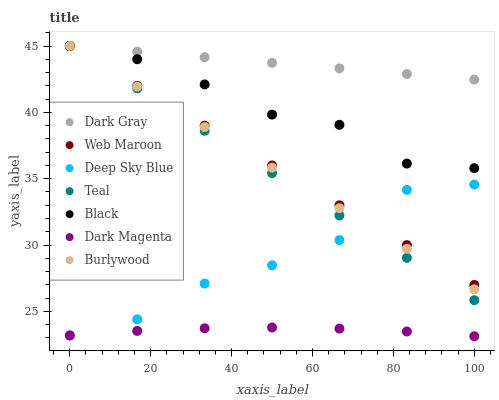Does Dark Magenta have the minimum area under the curve?
Answer yes or no. Yes. Does Dark Gray have the maximum area under the curve?
Answer yes or no. Yes. Does Burlywood have the minimum area under the curve?
Answer yes or no. No. Does Burlywood have the maximum area under the curve?
Answer yes or no. No. Is Teal the smoothest?
Answer yes or no. Yes. Is Deep Sky Blue the roughest?
Answer yes or no. Yes. Is Burlywood the smoothest?
Answer yes or no. No. Is Burlywood the roughest?
Answer yes or no. No. Does Dark Magenta have the lowest value?
Answer yes or no. Yes. Does Burlywood have the lowest value?
Answer yes or no. No. Does Teal have the highest value?
Answer yes or no. Yes. Does Dark Magenta have the highest value?
Answer yes or no. No. Is Dark Magenta less than Dark Gray?
Answer yes or no. Yes. Is Web Maroon greater than Dark Magenta?
Answer yes or no. Yes. Does Black intersect Burlywood?
Answer yes or no. Yes. Is Black less than Burlywood?
Answer yes or no. No. Is Black greater than Burlywood?
Answer yes or no. No. Does Dark Magenta intersect Dark Gray?
Answer yes or no. No. 